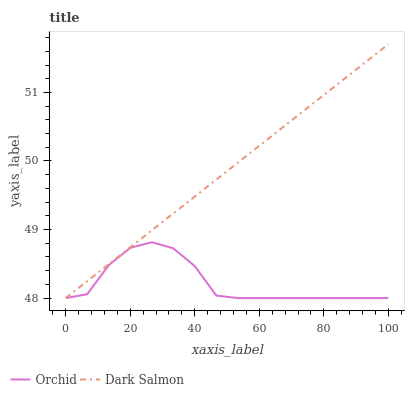Does Orchid have the minimum area under the curve?
Answer yes or no. Yes. Does Dark Salmon have the maximum area under the curve?
Answer yes or no. Yes. Does Orchid have the maximum area under the curve?
Answer yes or no. No. Is Dark Salmon the smoothest?
Answer yes or no. Yes. Is Orchid the roughest?
Answer yes or no. Yes. Is Orchid the smoothest?
Answer yes or no. No. Does Dark Salmon have the highest value?
Answer yes or no. Yes. Does Orchid have the highest value?
Answer yes or no. No. Does Dark Salmon intersect Orchid?
Answer yes or no. Yes. Is Dark Salmon less than Orchid?
Answer yes or no. No. Is Dark Salmon greater than Orchid?
Answer yes or no. No. 